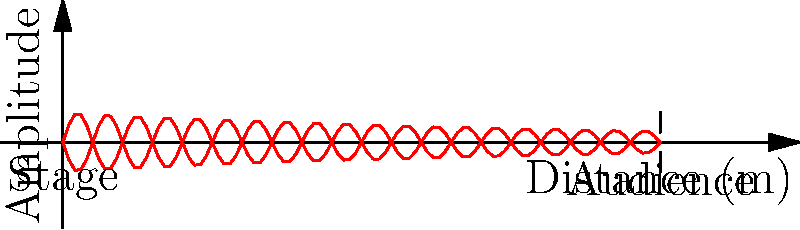As a council member supporting Kathak performances, you're consulted on the design of a new auditorium. The diagram shows sound wave propagation from the stage to the audience. If the frequency of the Ghungroo bells used in Kathak is 220 Hz, and the speed of sound is 343 m/s, what is the optimal distance between two consecutive sound-absorbing panels on the ceiling to prevent standing waves? To determine the optimal distance between sound-absorbing panels, we need to follow these steps:

1. Calculate the wavelength of the sound:
   The wavelength $\lambda$ is given by the formula: $\lambda = \frac{v}{f}$
   Where $v$ is the speed of sound and $f$ is the frequency.

   $\lambda = \frac{343 \text{ m/s}}{220 \text{ Hz}} = 1.56 \text{ m}$

2. Determine the distance for standing waves:
   Standing waves occur at multiples of half-wavelengths. To prevent them, we need to place absorbing panels at intervals that don't coincide with these multiples.

3. Calculate the optimal distance:
   The optimal distance would be at quarter-wavelength intervals. This ensures that any reflected sound waves are out of phase with the incident waves, leading to destructive interference.

   Optimal distance = $\frac{\lambda}{4} = \frac{1.56 \text{ m}}{4} = 0.39 \text{ m}$

This distance will help to reduce standing waves and create a more uniform sound distribution throughout the auditorium, enhancing the Kathak performance experience.
Answer: 0.39 m 